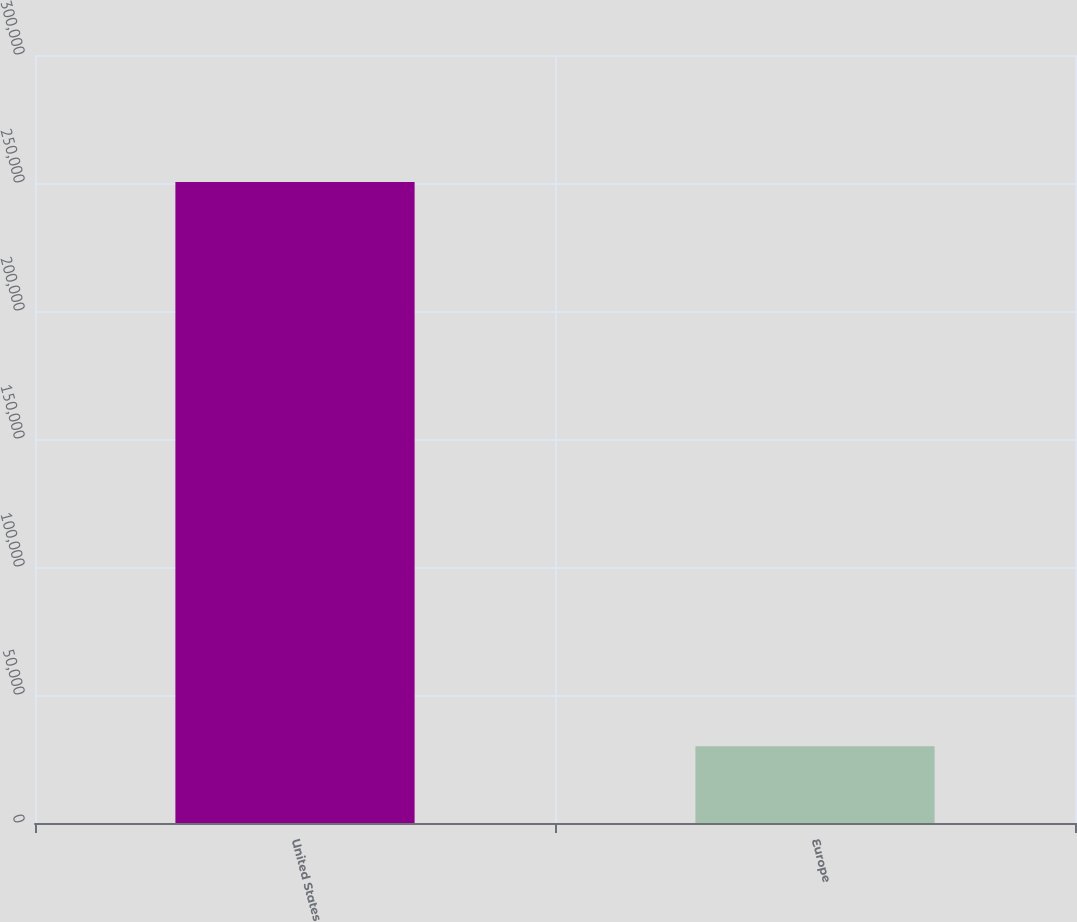Convert chart. <chart><loc_0><loc_0><loc_500><loc_500><bar_chart><fcel>United States<fcel>Europe<nl><fcel>250430<fcel>29996<nl></chart> 